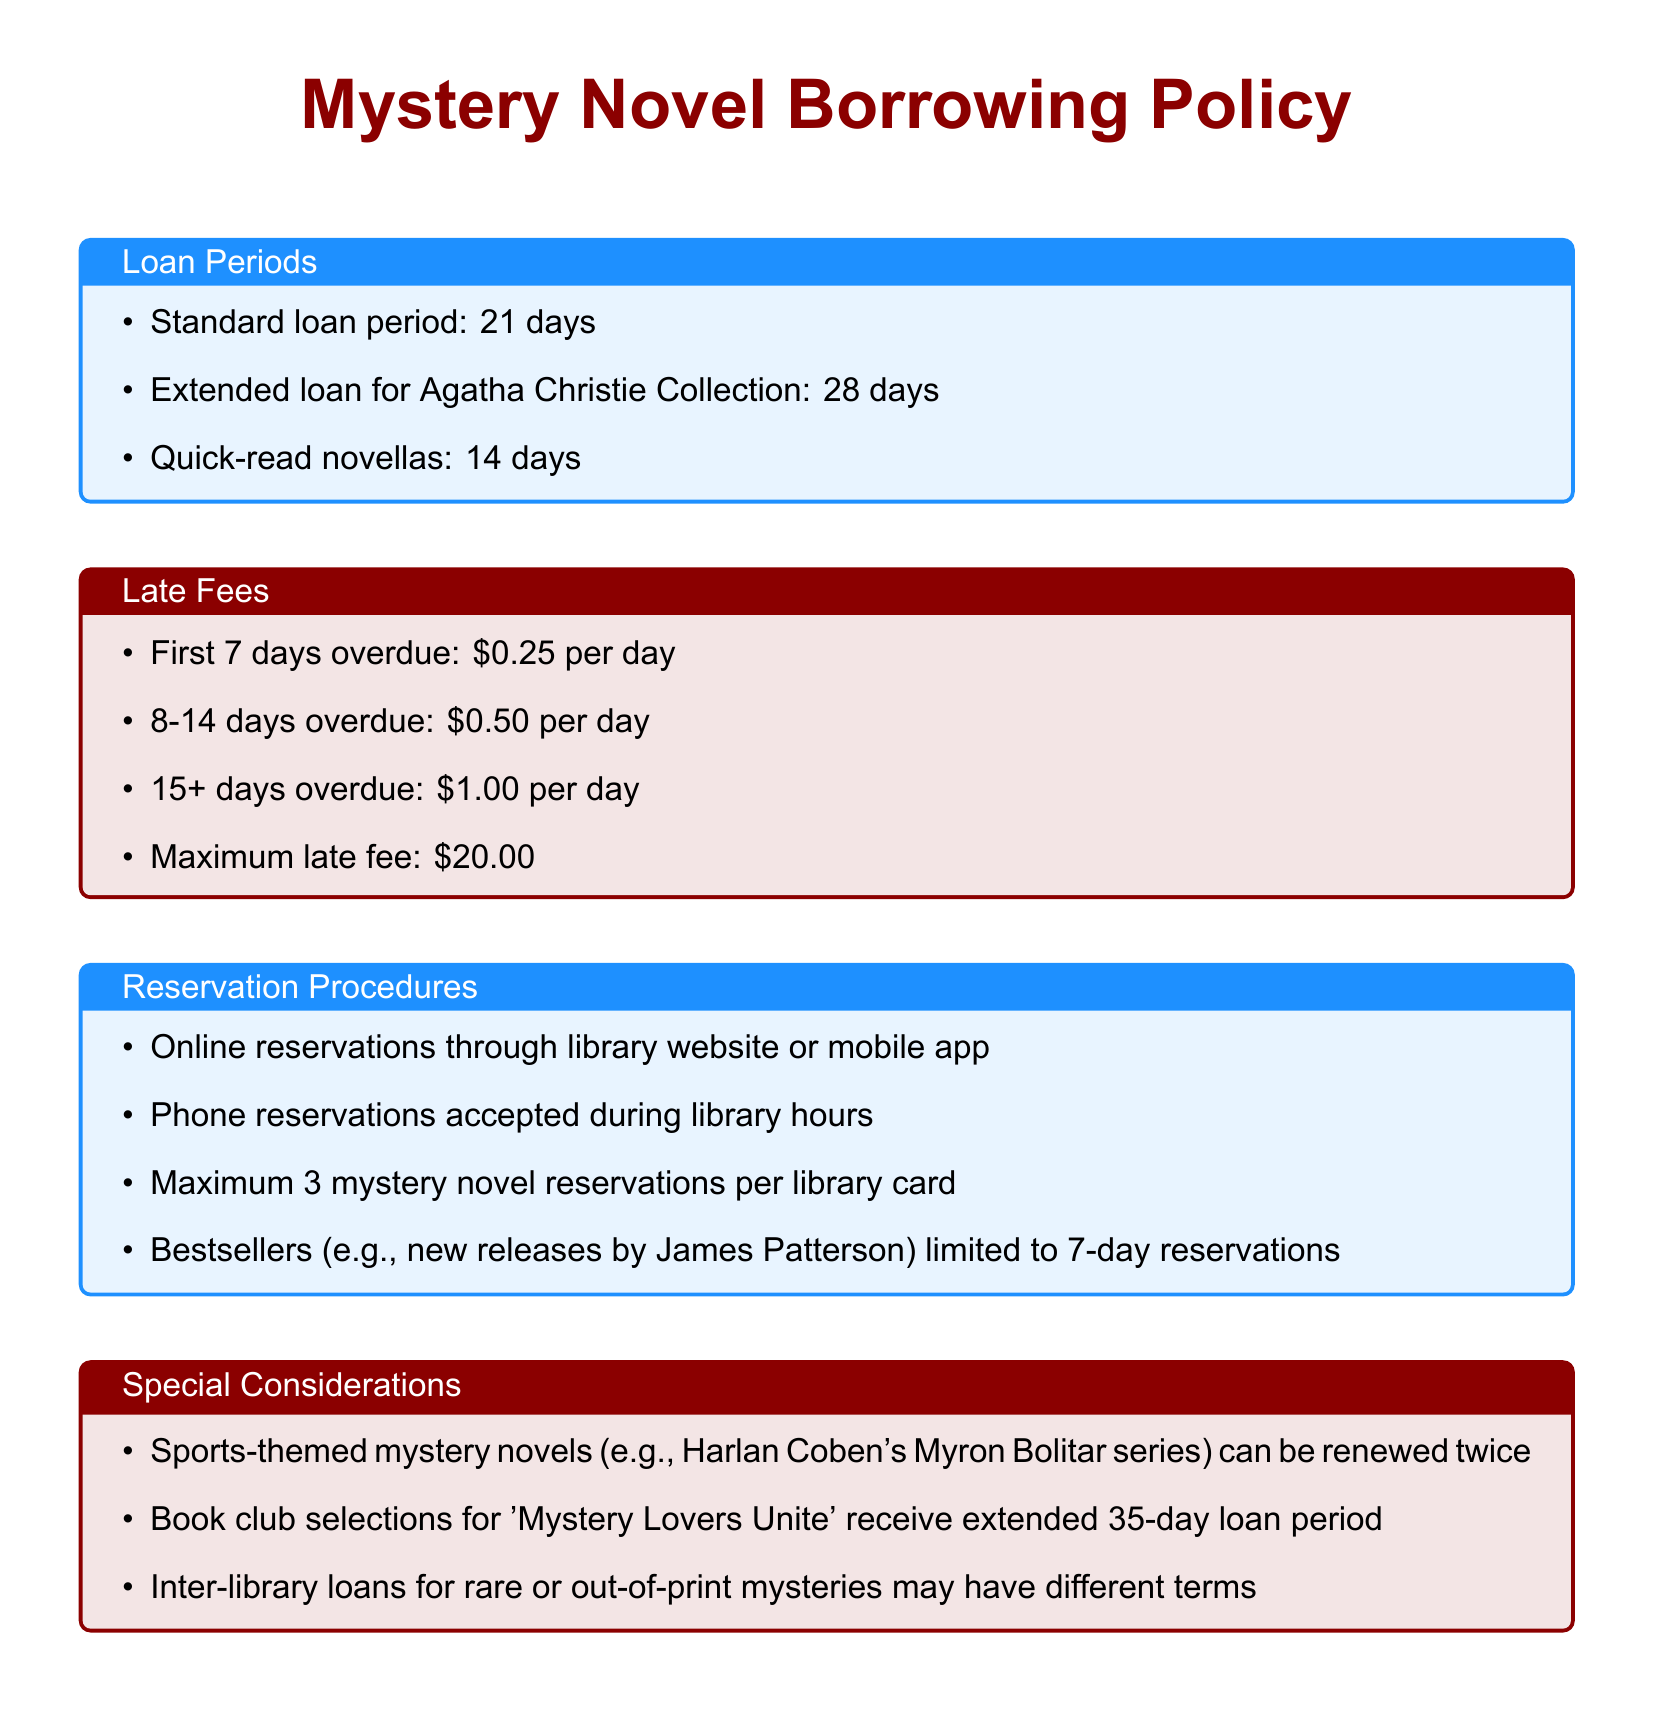What is the standard loan period for mystery novels? The standard loan period is specifically mentioned in the document as 21 days.
Answer: 21 days How much is the late fee for the first 7 days overdue? The document states the late fee for the first 7 days overdue is 0.25 per day.
Answer: 0.25 What is the maximum late fee allowed? According to the document, the maximum late fee mentioned is 20.00.
Answer: 20.00 How many mystery novels can be reserved with one library card? The document specifies that a maximum of 3 mystery novel reservations can be made per library card.
Answer: 3 What is the loan period for book club selections for 'Mystery Lovers Unite'? The document indicates that book club selections receive an extended loan period, specifically noted as 35 days.
Answer: 35 days How long is the loan period for Quick-read novellas? The document states that Quick-read novellas have a loan period of 14 days.
Answer: 14 days What is the late fee for 8-14 days overdue? The document highlights that the late fee for 8-14 days overdue is 0.50 per day.
Answer: 0.50 Can sports-themed mystery novels be renewed? The document indicates that sports-themed mystery novels can indeed be renewed, and this information is explicitly stated.
Answer: Yes 